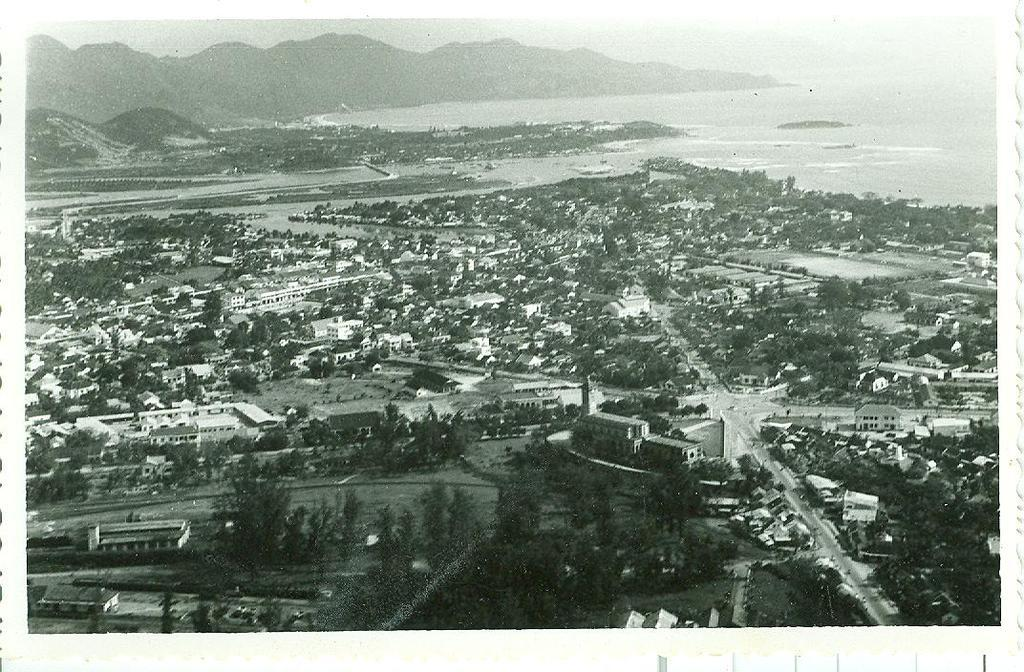What type of view is shown in the image? The image is an aerial view of a city. What types of structures can be seen in the image? There are houses, trees, buildings, and mountains visible in the image. Is there any water visible in the image? Yes, there is water visible in the image. What part of the city is shown in the image? The image shows the surface of the city. What shape is the straw in the image? There is no straw present in the image. What activity are the children participating in during recess in the image? There are no children or recess activity shown in the image; it is an aerial view of a city. 